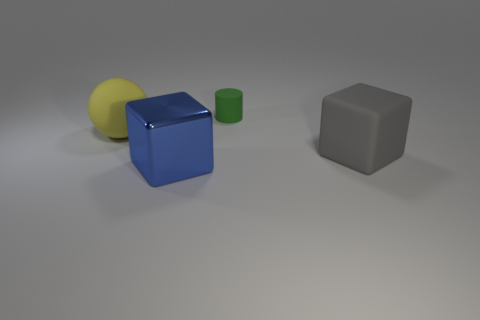How many other things are there of the same material as the tiny cylinder?
Your response must be concise. 2. There is a cube on the right side of the blue metal cube; how many yellow matte things are to the right of it?
Offer a terse response. 0. Is there any other thing that is the same shape as the metal thing?
Provide a succinct answer. Yes. Is the number of blue metallic cubes less than the number of large things?
Provide a succinct answer. Yes. What is the shape of the big matte thing behind the cube that is behind the metallic block?
Your answer should be very brief. Sphere. Is there anything else that is the same size as the green matte cylinder?
Provide a short and direct response. No. What shape is the thing that is behind the big rubber object to the left of the blue cube that is in front of the small rubber thing?
Offer a very short reply. Cylinder. What number of objects are either rubber things that are on the left side of the large blue shiny thing or objects that are in front of the rubber cylinder?
Offer a terse response. 3. There is a gray matte object; does it have the same size as the blue metal thing that is in front of the small green rubber thing?
Your answer should be compact. Yes. Is the large object behind the large rubber block made of the same material as the big cube that is behind the blue metal block?
Ensure brevity in your answer.  Yes. 